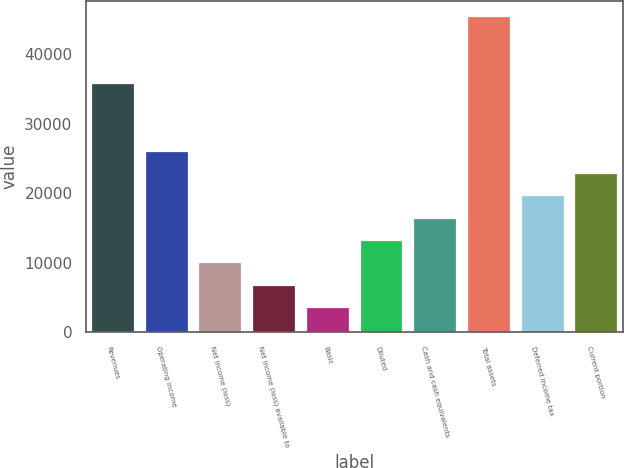Convert chart. <chart><loc_0><loc_0><loc_500><loc_500><bar_chart><fcel>Revenues<fcel>Operating income<fcel>Net income (loss)<fcel>Net income (loss) available to<fcel>Basic<fcel>Diluted<fcel>Cash and cash equivalents<fcel>Total assets<fcel>Deferred income tax<fcel>Current portion<nl><fcel>35763.5<fcel>26123<fcel>10055.5<fcel>6842<fcel>3628.5<fcel>13269<fcel>16482.5<fcel>45404<fcel>19696<fcel>22909.5<nl></chart> 